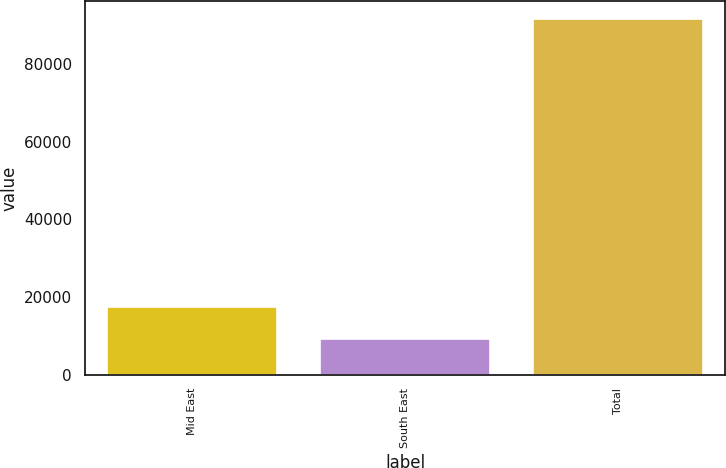Convert chart to OTSL. <chart><loc_0><loc_0><loc_500><loc_500><bar_chart><fcel>Mid East<fcel>South East<fcel>Total<nl><fcel>17374<fcel>9137<fcel>91507<nl></chart> 